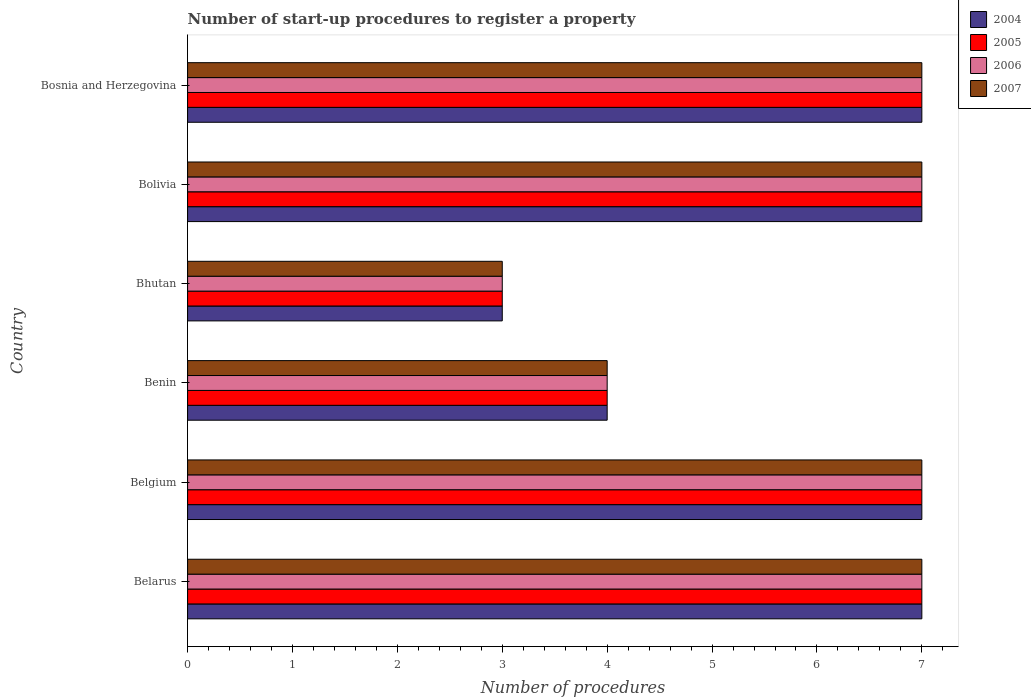Are the number of bars per tick equal to the number of legend labels?
Ensure brevity in your answer.  Yes. What is the label of the 5th group of bars from the top?
Keep it short and to the point. Belgium. What is the number of procedures required to register a property in 2005 in Bolivia?
Your response must be concise. 7. Across all countries, what is the minimum number of procedures required to register a property in 2005?
Keep it short and to the point. 3. In which country was the number of procedures required to register a property in 2007 maximum?
Provide a succinct answer. Belarus. In which country was the number of procedures required to register a property in 2006 minimum?
Make the answer very short. Bhutan. What is the difference between the number of procedures required to register a property in 2004 in Bolivia and the number of procedures required to register a property in 2005 in Benin?
Keep it short and to the point. 3. What is the average number of procedures required to register a property in 2007 per country?
Provide a short and direct response. 5.83. In how many countries, is the number of procedures required to register a property in 2007 greater than 5.2 ?
Offer a terse response. 4. What is the ratio of the number of procedures required to register a property in 2004 in Belarus to that in Belgium?
Your answer should be compact. 1. Is the number of procedures required to register a property in 2004 in Benin less than that in Bosnia and Herzegovina?
Provide a short and direct response. Yes. What is the difference between the highest and the second highest number of procedures required to register a property in 2007?
Keep it short and to the point. 0. What does the 3rd bar from the top in Belarus represents?
Provide a short and direct response. 2005. Is it the case that in every country, the sum of the number of procedures required to register a property in 2005 and number of procedures required to register a property in 2004 is greater than the number of procedures required to register a property in 2006?
Provide a short and direct response. Yes. How many bars are there?
Provide a succinct answer. 24. Are all the bars in the graph horizontal?
Offer a very short reply. Yes. How many countries are there in the graph?
Give a very brief answer. 6. Are the values on the major ticks of X-axis written in scientific E-notation?
Offer a very short reply. No. Does the graph contain any zero values?
Your answer should be compact. No. Does the graph contain grids?
Your response must be concise. No. What is the title of the graph?
Offer a terse response. Number of start-up procedures to register a property. Does "1989" appear as one of the legend labels in the graph?
Give a very brief answer. No. What is the label or title of the X-axis?
Your answer should be very brief. Number of procedures. What is the Number of procedures in 2004 in Belarus?
Make the answer very short. 7. What is the Number of procedures of 2006 in Benin?
Your answer should be very brief. 4. What is the Number of procedures of 2007 in Benin?
Offer a very short reply. 4. What is the Number of procedures of 2005 in Bhutan?
Make the answer very short. 3. What is the Number of procedures of 2006 in Bhutan?
Ensure brevity in your answer.  3. What is the Number of procedures of 2007 in Bhutan?
Your response must be concise. 3. What is the Number of procedures in 2005 in Bolivia?
Keep it short and to the point. 7. What is the Number of procedures of 2006 in Bolivia?
Offer a very short reply. 7. What is the Number of procedures in 2005 in Bosnia and Herzegovina?
Your answer should be very brief. 7. What is the Number of procedures of 2006 in Bosnia and Herzegovina?
Ensure brevity in your answer.  7. Across all countries, what is the maximum Number of procedures in 2004?
Your answer should be very brief. 7. Across all countries, what is the maximum Number of procedures of 2005?
Ensure brevity in your answer.  7. Across all countries, what is the maximum Number of procedures in 2006?
Ensure brevity in your answer.  7. Across all countries, what is the minimum Number of procedures of 2004?
Ensure brevity in your answer.  3. Across all countries, what is the minimum Number of procedures of 2007?
Your answer should be very brief. 3. What is the total Number of procedures of 2004 in the graph?
Your answer should be very brief. 35. What is the total Number of procedures of 2005 in the graph?
Offer a terse response. 35. What is the total Number of procedures in 2006 in the graph?
Your response must be concise. 35. What is the total Number of procedures in 2007 in the graph?
Your answer should be very brief. 35. What is the difference between the Number of procedures of 2006 in Belarus and that in Belgium?
Your answer should be compact. 0. What is the difference between the Number of procedures in 2007 in Belarus and that in Belgium?
Ensure brevity in your answer.  0. What is the difference between the Number of procedures of 2004 in Belarus and that in Benin?
Your response must be concise. 3. What is the difference between the Number of procedures of 2006 in Belarus and that in Benin?
Provide a short and direct response. 3. What is the difference between the Number of procedures of 2005 in Belarus and that in Bhutan?
Provide a short and direct response. 4. What is the difference between the Number of procedures of 2005 in Belarus and that in Bolivia?
Keep it short and to the point. 0. What is the difference between the Number of procedures of 2007 in Belarus and that in Bolivia?
Your answer should be very brief. 0. What is the difference between the Number of procedures of 2004 in Belarus and that in Bosnia and Herzegovina?
Offer a terse response. 0. What is the difference between the Number of procedures in 2007 in Belarus and that in Bosnia and Herzegovina?
Offer a very short reply. 0. What is the difference between the Number of procedures in 2007 in Belgium and that in Bhutan?
Provide a succinct answer. 4. What is the difference between the Number of procedures in 2004 in Belgium and that in Bolivia?
Offer a very short reply. 0. What is the difference between the Number of procedures of 2005 in Belgium and that in Bolivia?
Ensure brevity in your answer.  0. What is the difference between the Number of procedures in 2006 in Belgium and that in Bolivia?
Offer a terse response. 0. What is the difference between the Number of procedures in 2007 in Belgium and that in Bolivia?
Make the answer very short. 0. What is the difference between the Number of procedures of 2004 in Belgium and that in Bosnia and Herzegovina?
Provide a short and direct response. 0. What is the difference between the Number of procedures in 2005 in Belgium and that in Bosnia and Herzegovina?
Give a very brief answer. 0. What is the difference between the Number of procedures in 2007 in Belgium and that in Bosnia and Herzegovina?
Offer a terse response. 0. What is the difference between the Number of procedures in 2004 in Benin and that in Bhutan?
Provide a short and direct response. 1. What is the difference between the Number of procedures in 2005 in Benin and that in Bhutan?
Keep it short and to the point. 1. What is the difference between the Number of procedures of 2005 in Benin and that in Bolivia?
Offer a terse response. -3. What is the difference between the Number of procedures of 2007 in Benin and that in Bolivia?
Make the answer very short. -3. What is the difference between the Number of procedures in 2004 in Benin and that in Bosnia and Herzegovina?
Your response must be concise. -3. What is the difference between the Number of procedures in 2005 in Benin and that in Bosnia and Herzegovina?
Keep it short and to the point. -3. What is the difference between the Number of procedures of 2007 in Benin and that in Bosnia and Herzegovina?
Provide a succinct answer. -3. What is the difference between the Number of procedures in 2004 in Bhutan and that in Bolivia?
Keep it short and to the point. -4. What is the difference between the Number of procedures in 2007 in Bhutan and that in Bolivia?
Ensure brevity in your answer.  -4. What is the difference between the Number of procedures of 2004 in Bhutan and that in Bosnia and Herzegovina?
Your answer should be compact. -4. What is the difference between the Number of procedures of 2005 in Bhutan and that in Bosnia and Herzegovina?
Keep it short and to the point. -4. What is the difference between the Number of procedures of 2007 in Bhutan and that in Bosnia and Herzegovina?
Ensure brevity in your answer.  -4. What is the difference between the Number of procedures in 2005 in Bolivia and that in Bosnia and Herzegovina?
Your answer should be compact. 0. What is the difference between the Number of procedures of 2007 in Bolivia and that in Bosnia and Herzegovina?
Make the answer very short. 0. What is the difference between the Number of procedures in 2004 in Belarus and the Number of procedures in 2005 in Belgium?
Keep it short and to the point. 0. What is the difference between the Number of procedures in 2004 in Belarus and the Number of procedures in 2006 in Belgium?
Make the answer very short. 0. What is the difference between the Number of procedures in 2004 in Belarus and the Number of procedures in 2007 in Belgium?
Make the answer very short. 0. What is the difference between the Number of procedures in 2005 in Belarus and the Number of procedures in 2007 in Belgium?
Offer a terse response. 0. What is the difference between the Number of procedures of 2004 in Belarus and the Number of procedures of 2005 in Benin?
Make the answer very short. 3. What is the difference between the Number of procedures of 2004 in Belarus and the Number of procedures of 2006 in Benin?
Make the answer very short. 3. What is the difference between the Number of procedures in 2004 in Belarus and the Number of procedures in 2007 in Benin?
Offer a terse response. 3. What is the difference between the Number of procedures of 2004 in Belarus and the Number of procedures of 2006 in Bhutan?
Provide a succinct answer. 4. What is the difference between the Number of procedures in 2005 in Belarus and the Number of procedures in 2006 in Bhutan?
Your response must be concise. 4. What is the difference between the Number of procedures in 2005 in Belarus and the Number of procedures in 2007 in Bhutan?
Provide a succinct answer. 4. What is the difference between the Number of procedures of 2006 in Belarus and the Number of procedures of 2007 in Bhutan?
Your answer should be very brief. 4. What is the difference between the Number of procedures of 2004 in Belarus and the Number of procedures of 2005 in Bolivia?
Offer a very short reply. 0. What is the difference between the Number of procedures of 2004 in Belarus and the Number of procedures of 2006 in Bolivia?
Your answer should be very brief. 0. What is the difference between the Number of procedures in 2004 in Belarus and the Number of procedures in 2007 in Bolivia?
Your answer should be very brief. 0. What is the difference between the Number of procedures of 2005 in Belarus and the Number of procedures of 2006 in Bolivia?
Make the answer very short. 0. What is the difference between the Number of procedures in 2005 in Belarus and the Number of procedures in 2007 in Bolivia?
Your answer should be very brief. 0. What is the difference between the Number of procedures in 2006 in Belarus and the Number of procedures in 2007 in Bolivia?
Give a very brief answer. 0. What is the difference between the Number of procedures of 2005 in Belarus and the Number of procedures of 2006 in Bosnia and Herzegovina?
Offer a terse response. 0. What is the difference between the Number of procedures in 2005 in Belarus and the Number of procedures in 2007 in Bosnia and Herzegovina?
Your answer should be very brief. 0. What is the difference between the Number of procedures of 2004 in Belgium and the Number of procedures of 2006 in Benin?
Your answer should be compact. 3. What is the difference between the Number of procedures of 2004 in Belgium and the Number of procedures of 2007 in Benin?
Offer a terse response. 3. What is the difference between the Number of procedures in 2005 in Belgium and the Number of procedures in 2007 in Benin?
Your response must be concise. 3. What is the difference between the Number of procedures of 2006 in Belgium and the Number of procedures of 2007 in Benin?
Your response must be concise. 3. What is the difference between the Number of procedures of 2004 in Belgium and the Number of procedures of 2006 in Bhutan?
Your answer should be very brief. 4. What is the difference between the Number of procedures of 2004 in Belgium and the Number of procedures of 2006 in Bolivia?
Offer a terse response. 0. What is the difference between the Number of procedures of 2005 in Belgium and the Number of procedures of 2006 in Bolivia?
Your answer should be compact. 0. What is the difference between the Number of procedures of 2005 in Belgium and the Number of procedures of 2007 in Bolivia?
Your answer should be compact. 0. What is the difference between the Number of procedures of 2006 in Belgium and the Number of procedures of 2007 in Bolivia?
Your response must be concise. 0. What is the difference between the Number of procedures in 2004 in Belgium and the Number of procedures in 2005 in Bosnia and Herzegovina?
Your response must be concise. 0. What is the difference between the Number of procedures in 2004 in Belgium and the Number of procedures in 2006 in Bosnia and Herzegovina?
Your answer should be compact. 0. What is the difference between the Number of procedures in 2005 in Belgium and the Number of procedures in 2007 in Bosnia and Herzegovina?
Provide a succinct answer. 0. What is the difference between the Number of procedures in 2004 in Benin and the Number of procedures in 2005 in Bhutan?
Provide a short and direct response. 1. What is the difference between the Number of procedures in 2005 in Benin and the Number of procedures in 2007 in Bhutan?
Offer a terse response. 1. What is the difference between the Number of procedures in 2004 in Benin and the Number of procedures in 2007 in Bolivia?
Provide a succinct answer. -3. What is the difference between the Number of procedures in 2006 in Benin and the Number of procedures in 2007 in Bolivia?
Provide a short and direct response. -3. What is the difference between the Number of procedures of 2004 in Benin and the Number of procedures of 2007 in Bosnia and Herzegovina?
Provide a succinct answer. -3. What is the difference between the Number of procedures of 2005 in Benin and the Number of procedures of 2006 in Bosnia and Herzegovina?
Ensure brevity in your answer.  -3. What is the difference between the Number of procedures in 2004 in Bhutan and the Number of procedures in 2006 in Bolivia?
Keep it short and to the point. -4. What is the difference between the Number of procedures of 2004 in Bhutan and the Number of procedures of 2007 in Bolivia?
Offer a terse response. -4. What is the difference between the Number of procedures of 2006 in Bhutan and the Number of procedures of 2007 in Bolivia?
Provide a short and direct response. -4. What is the difference between the Number of procedures of 2004 in Bhutan and the Number of procedures of 2007 in Bosnia and Herzegovina?
Your response must be concise. -4. What is the difference between the Number of procedures in 2006 in Bhutan and the Number of procedures in 2007 in Bosnia and Herzegovina?
Keep it short and to the point. -4. What is the difference between the Number of procedures of 2004 in Bolivia and the Number of procedures of 2005 in Bosnia and Herzegovina?
Ensure brevity in your answer.  0. What is the difference between the Number of procedures of 2004 in Bolivia and the Number of procedures of 2007 in Bosnia and Herzegovina?
Offer a very short reply. 0. What is the difference between the Number of procedures of 2005 in Bolivia and the Number of procedures of 2007 in Bosnia and Herzegovina?
Your answer should be compact. 0. What is the average Number of procedures of 2004 per country?
Your answer should be compact. 5.83. What is the average Number of procedures in 2005 per country?
Offer a very short reply. 5.83. What is the average Number of procedures of 2006 per country?
Your answer should be compact. 5.83. What is the average Number of procedures of 2007 per country?
Give a very brief answer. 5.83. What is the difference between the Number of procedures in 2004 and Number of procedures in 2005 in Belarus?
Give a very brief answer. 0. What is the difference between the Number of procedures in 2004 and Number of procedures in 2006 in Belarus?
Keep it short and to the point. 0. What is the difference between the Number of procedures of 2004 and Number of procedures of 2007 in Belarus?
Offer a terse response. 0. What is the difference between the Number of procedures of 2005 and Number of procedures of 2006 in Belarus?
Your answer should be very brief. 0. What is the difference between the Number of procedures of 2005 and Number of procedures of 2007 in Belarus?
Your answer should be compact. 0. What is the difference between the Number of procedures of 2004 and Number of procedures of 2005 in Belgium?
Your answer should be compact. 0. What is the difference between the Number of procedures of 2004 and Number of procedures of 2006 in Benin?
Give a very brief answer. 0. What is the difference between the Number of procedures in 2004 and Number of procedures in 2007 in Benin?
Keep it short and to the point. 0. What is the difference between the Number of procedures in 2005 and Number of procedures in 2007 in Benin?
Keep it short and to the point. 0. What is the difference between the Number of procedures of 2006 and Number of procedures of 2007 in Benin?
Offer a terse response. 0. What is the difference between the Number of procedures of 2004 and Number of procedures of 2005 in Bhutan?
Ensure brevity in your answer.  0. What is the difference between the Number of procedures in 2004 and Number of procedures in 2007 in Bhutan?
Your answer should be compact. 0. What is the difference between the Number of procedures in 2005 and Number of procedures in 2007 in Bhutan?
Give a very brief answer. 0. What is the difference between the Number of procedures of 2006 and Number of procedures of 2007 in Bhutan?
Make the answer very short. 0. What is the difference between the Number of procedures in 2004 and Number of procedures in 2007 in Bolivia?
Make the answer very short. 0. What is the difference between the Number of procedures of 2006 and Number of procedures of 2007 in Bolivia?
Provide a succinct answer. 0. What is the difference between the Number of procedures of 2004 and Number of procedures of 2006 in Bosnia and Herzegovina?
Ensure brevity in your answer.  0. What is the difference between the Number of procedures of 2006 and Number of procedures of 2007 in Bosnia and Herzegovina?
Offer a very short reply. 0. What is the ratio of the Number of procedures of 2004 in Belarus to that in Belgium?
Offer a terse response. 1. What is the ratio of the Number of procedures in 2005 in Belarus to that in Belgium?
Ensure brevity in your answer.  1. What is the ratio of the Number of procedures in 2007 in Belarus to that in Belgium?
Offer a very short reply. 1. What is the ratio of the Number of procedures in 2004 in Belarus to that in Bhutan?
Give a very brief answer. 2.33. What is the ratio of the Number of procedures of 2005 in Belarus to that in Bhutan?
Make the answer very short. 2.33. What is the ratio of the Number of procedures in 2006 in Belarus to that in Bhutan?
Offer a terse response. 2.33. What is the ratio of the Number of procedures of 2007 in Belarus to that in Bhutan?
Keep it short and to the point. 2.33. What is the ratio of the Number of procedures in 2005 in Belarus to that in Bolivia?
Your answer should be very brief. 1. What is the ratio of the Number of procedures of 2007 in Belarus to that in Bolivia?
Provide a short and direct response. 1. What is the ratio of the Number of procedures of 2004 in Belarus to that in Bosnia and Herzegovina?
Make the answer very short. 1. What is the ratio of the Number of procedures of 2007 in Belarus to that in Bosnia and Herzegovina?
Give a very brief answer. 1. What is the ratio of the Number of procedures in 2006 in Belgium to that in Benin?
Provide a short and direct response. 1.75. What is the ratio of the Number of procedures in 2004 in Belgium to that in Bhutan?
Your answer should be compact. 2.33. What is the ratio of the Number of procedures in 2005 in Belgium to that in Bhutan?
Offer a very short reply. 2.33. What is the ratio of the Number of procedures in 2006 in Belgium to that in Bhutan?
Your response must be concise. 2.33. What is the ratio of the Number of procedures in 2007 in Belgium to that in Bhutan?
Your response must be concise. 2.33. What is the ratio of the Number of procedures in 2004 in Belgium to that in Bolivia?
Offer a very short reply. 1. What is the ratio of the Number of procedures in 2006 in Belgium to that in Bolivia?
Provide a succinct answer. 1. What is the ratio of the Number of procedures of 2004 in Belgium to that in Bosnia and Herzegovina?
Ensure brevity in your answer.  1. What is the ratio of the Number of procedures in 2005 in Belgium to that in Bosnia and Herzegovina?
Provide a succinct answer. 1. What is the ratio of the Number of procedures in 2007 in Belgium to that in Bosnia and Herzegovina?
Your answer should be very brief. 1. What is the ratio of the Number of procedures of 2005 in Benin to that in Bhutan?
Your answer should be very brief. 1.33. What is the ratio of the Number of procedures in 2007 in Benin to that in Bhutan?
Keep it short and to the point. 1.33. What is the ratio of the Number of procedures in 2004 in Benin to that in Bolivia?
Your answer should be compact. 0.57. What is the ratio of the Number of procedures of 2005 in Benin to that in Bolivia?
Provide a succinct answer. 0.57. What is the ratio of the Number of procedures of 2007 in Benin to that in Bolivia?
Provide a short and direct response. 0.57. What is the ratio of the Number of procedures in 2004 in Benin to that in Bosnia and Herzegovina?
Offer a very short reply. 0.57. What is the ratio of the Number of procedures of 2005 in Benin to that in Bosnia and Herzegovina?
Ensure brevity in your answer.  0.57. What is the ratio of the Number of procedures in 2004 in Bhutan to that in Bolivia?
Keep it short and to the point. 0.43. What is the ratio of the Number of procedures of 2005 in Bhutan to that in Bolivia?
Provide a short and direct response. 0.43. What is the ratio of the Number of procedures in 2006 in Bhutan to that in Bolivia?
Ensure brevity in your answer.  0.43. What is the ratio of the Number of procedures of 2007 in Bhutan to that in Bolivia?
Give a very brief answer. 0.43. What is the ratio of the Number of procedures in 2004 in Bhutan to that in Bosnia and Herzegovina?
Provide a short and direct response. 0.43. What is the ratio of the Number of procedures in 2005 in Bhutan to that in Bosnia and Herzegovina?
Your answer should be very brief. 0.43. What is the ratio of the Number of procedures in 2006 in Bhutan to that in Bosnia and Herzegovina?
Your answer should be compact. 0.43. What is the ratio of the Number of procedures in 2007 in Bhutan to that in Bosnia and Herzegovina?
Your answer should be very brief. 0.43. What is the ratio of the Number of procedures of 2005 in Bolivia to that in Bosnia and Herzegovina?
Your answer should be very brief. 1. What is the ratio of the Number of procedures of 2006 in Bolivia to that in Bosnia and Herzegovina?
Offer a terse response. 1. What is the difference between the highest and the second highest Number of procedures of 2004?
Your answer should be very brief. 0. What is the difference between the highest and the second highest Number of procedures of 2005?
Provide a succinct answer. 0. What is the difference between the highest and the second highest Number of procedures in 2006?
Make the answer very short. 0. What is the difference between the highest and the second highest Number of procedures of 2007?
Offer a terse response. 0. What is the difference between the highest and the lowest Number of procedures of 2005?
Your answer should be very brief. 4. What is the difference between the highest and the lowest Number of procedures of 2006?
Ensure brevity in your answer.  4. What is the difference between the highest and the lowest Number of procedures in 2007?
Keep it short and to the point. 4. 